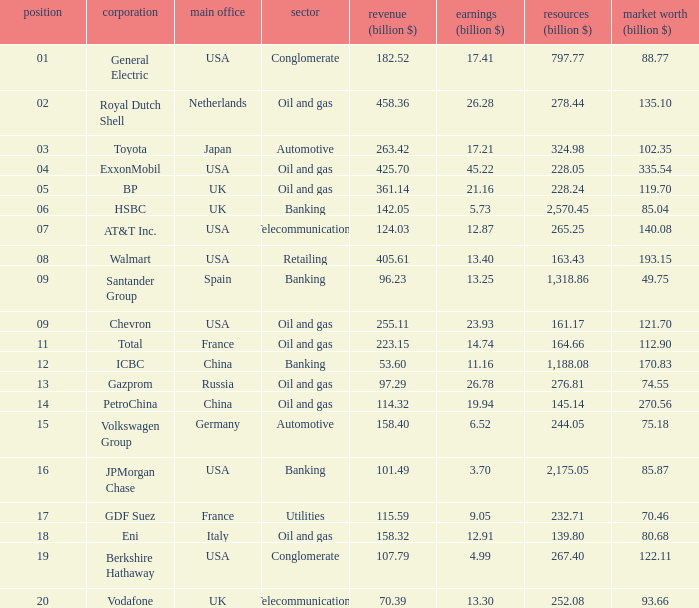Name the lowest Profits (billion $) which has a Sales (billion $) of 425.7, and a Rank larger than 4? None. 